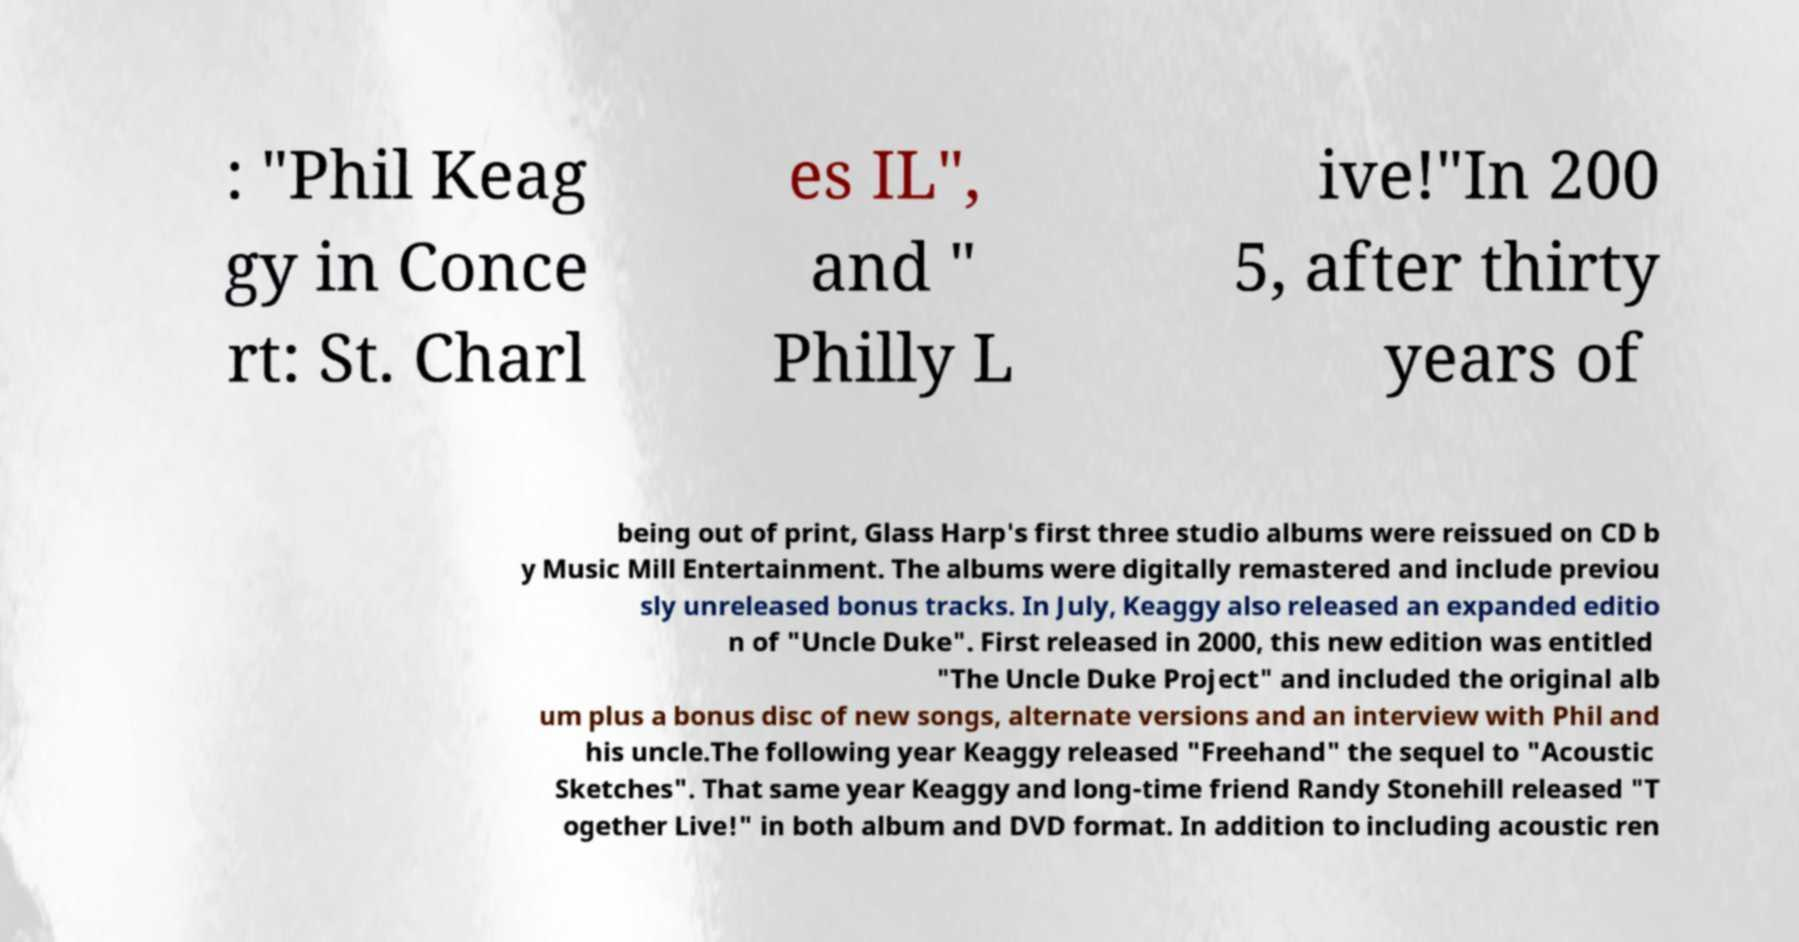For documentation purposes, I need the text within this image transcribed. Could you provide that? : "Phil Keag gy in Conce rt: St. Charl es IL", and " Philly L ive!"In 200 5, after thirty years of being out of print, Glass Harp's first three studio albums were reissued on CD b y Music Mill Entertainment. The albums were digitally remastered and include previou sly unreleased bonus tracks. In July, Keaggy also released an expanded editio n of "Uncle Duke". First released in 2000, this new edition was entitled "The Uncle Duke Project" and included the original alb um plus a bonus disc of new songs, alternate versions and an interview with Phil and his uncle.The following year Keaggy released "Freehand" the sequel to "Acoustic Sketches". That same year Keaggy and long-time friend Randy Stonehill released "T ogether Live!" in both album and DVD format. In addition to including acoustic ren 